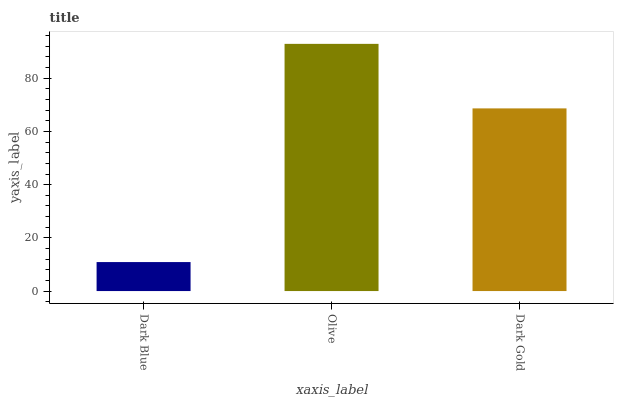Is Dark Blue the minimum?
Answer yes or no. Yes. Is Olive the maximum?
Answer yes or no. Yes. Is Dark Gold the minimum?
Answer yes or no. No. Is Dark Gold the maximum?
Answer yes or no. No. Is Olive greater than Dark Gold?
Answer yes or no. Yes. Is Dark Gold less than Olive?
Answer yes or no. Yes. Is Dark Gold greater than Olive?
Answer yes or no. No. Is Olive less than Dark Gold?
Answer yes or no. No. Is Dark Gold the high median?
Answer yes or no. Yes. Is Dark Gold the low median?
Answer yes or no. Yes. Is Olive the high median?
Answer yes or no. No. Is Olive the low median?
Answer yes or no. No. 